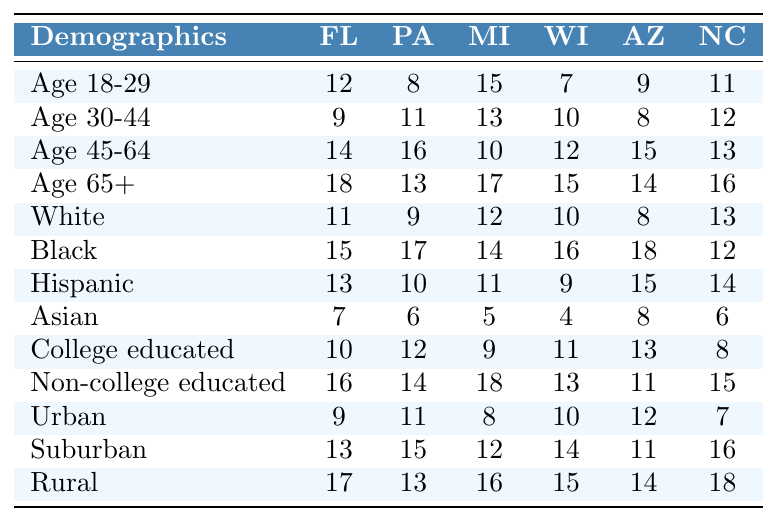What is the percentage of undecided voters aged 18-29 in Florida? In Florida, the value for undecided voters aged 18-29 is 12. To express this as a percentage, it remains as is, since the values are already given in percentage format.
Answer: 12% Which state has the highest percentage of Black undecided voters? The percentage of Black undecided voters is compared across states; Florida has 15, Pennsylvania has 17, Michigan has 14, Wisconsin has 16, Arizona has 18, and North Carolina has 12. Arizona has the highest value at 18.
Answer: Arizona What is the average percentage of undecided voters aged 65+ across all states? To find the average, sum the values for Age 65+ across the six states (18 + 13 + 17 + 15 + 14 + 16 = 93). There are 6 states, so the average is 93 / 6 = 15.5.
Answer: 15.5% Are there more undecided urban voters or rural voters in North Carolina? The percentage of undecided rural voters in North Carolina is 18, while urban voters are 7. Since 18 is greater than 7, there are more rural voters than urban voters in NC.
Answer: Yes What is the difference in percentage of undecided Hispanic voters between Wisconsin and Arizona? Wisconsin has 9% undecided Hispanic voters and Arizona has 15%. The difference is calculated by subtracting the two: 15 - 9 = 6.
Answer: 6% Which demographic has the lowest percentage of undecided voters in Michigan? In Michigan, we look for the lowest percentage; the values are 15 (Age 18-29), 13 (Age 30-44), 10 (Age 45-64), 17 (Age 65+), 12 (White), 14 (Black), 11 (Hispanic), 5 (Asian), 9 (College educated), 18 (Non-college educated), 8 (Urban), 12 (Suburban), 16 (Rural). The lowest percentage is 5 for Asian voters.
Answer: Asian How does the percentage of undecided college-educated voters in Florida compare to non-college educated voters in North Carolina? The percentage for Florida College educated is 10% and for North Carolina Non-college educated it is 15%. Comparing these: 10 is less than 15.
Answer: College educated voters in Florida are fewer What is the total percentage of undecided voters aged 30-44 across all states? The percentages for Age 30-44 are 9 (Florida) + 11 (Pennsylvania) + 13 (Michigan) + 10 (Wisconsin) + 8 (Arizona) + 12 (North Carolina) = 63.
Answer: 63 Which state has the largest proportion of undecided voters in the rural demographic? The rural demographic percentages are examined: Florida has 17, Pennsylvania 13, Michigan 16, Wisconsin 15, Arizona 14, North Carolina 18. The highest value is in North Carolina with 18%.
Answer: North Carolina Is there a higher percentage of undecided voters aged 45-64 in Arizona compared to Florida? The percentages for Arizona (15) and Florida (14) are compared. Since 15 is greater than 14, Arizona has a higher percentage.
Answer: Yes 